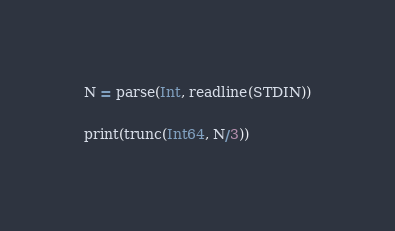<code> <loc_0><loc_0><loc_500><loc_500><_Julia_>N = parse(Int, readline(STDIN))

print(trunc(Int64, N/3))</code> 